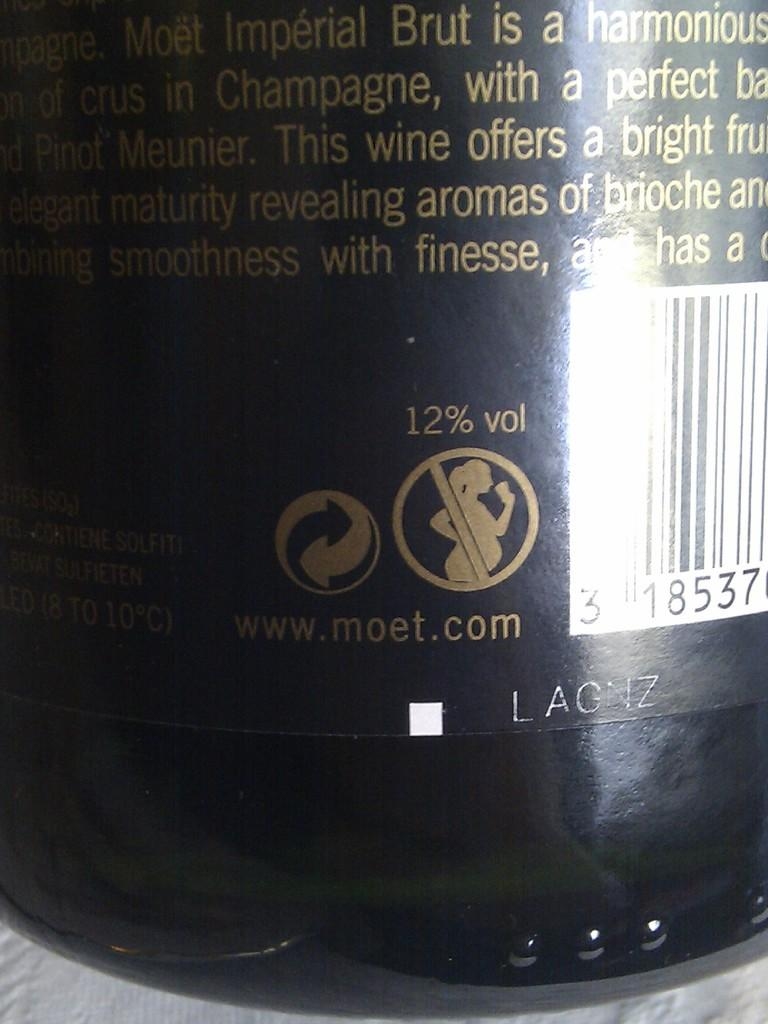<image>
Share a concise interpretation of the image provided. A bottle of Moet alcohol that contains 12% alcohol 